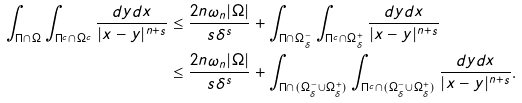Convert formula to latex. <formula><loc_0><loc_0><loc_500><loc_500>\int _ { \Pi \cap \Omega } \int _ { \Pi ^ { c } \cap \Omega ^ { c } } \frac { d y d x } { | x - y | ^ { n + s } } & \leq \frac { 2 n \omega _ { n } | \Omega | } { s \delta ^ { s } } + \int _ { \Pi \cap \Omega _ { \delta } ^ { - } } \int _ { \Pi ^ { c } \cap \Omega _ { \delta } ^ { + } } \frac { d y d x } { | x - y | ^ { n + s } } \\ & \leq \frac { 2 n \omega _ { n } | \Omega | } { s \delta ^ { s } } + \int _ { \Pi \cap ( \Omega _ { \delta } ^ { - } \cup \Omega _ { \delta } ^ { + } ) } \int _ { \Pi ^ { c } \cap ( \Omega _ { \delta } ^ { - } \cup \Omega _ { \delta } ^ { + } ) } \frac { d y d x } { | x - y | ^ { n + s } } .</formula> 